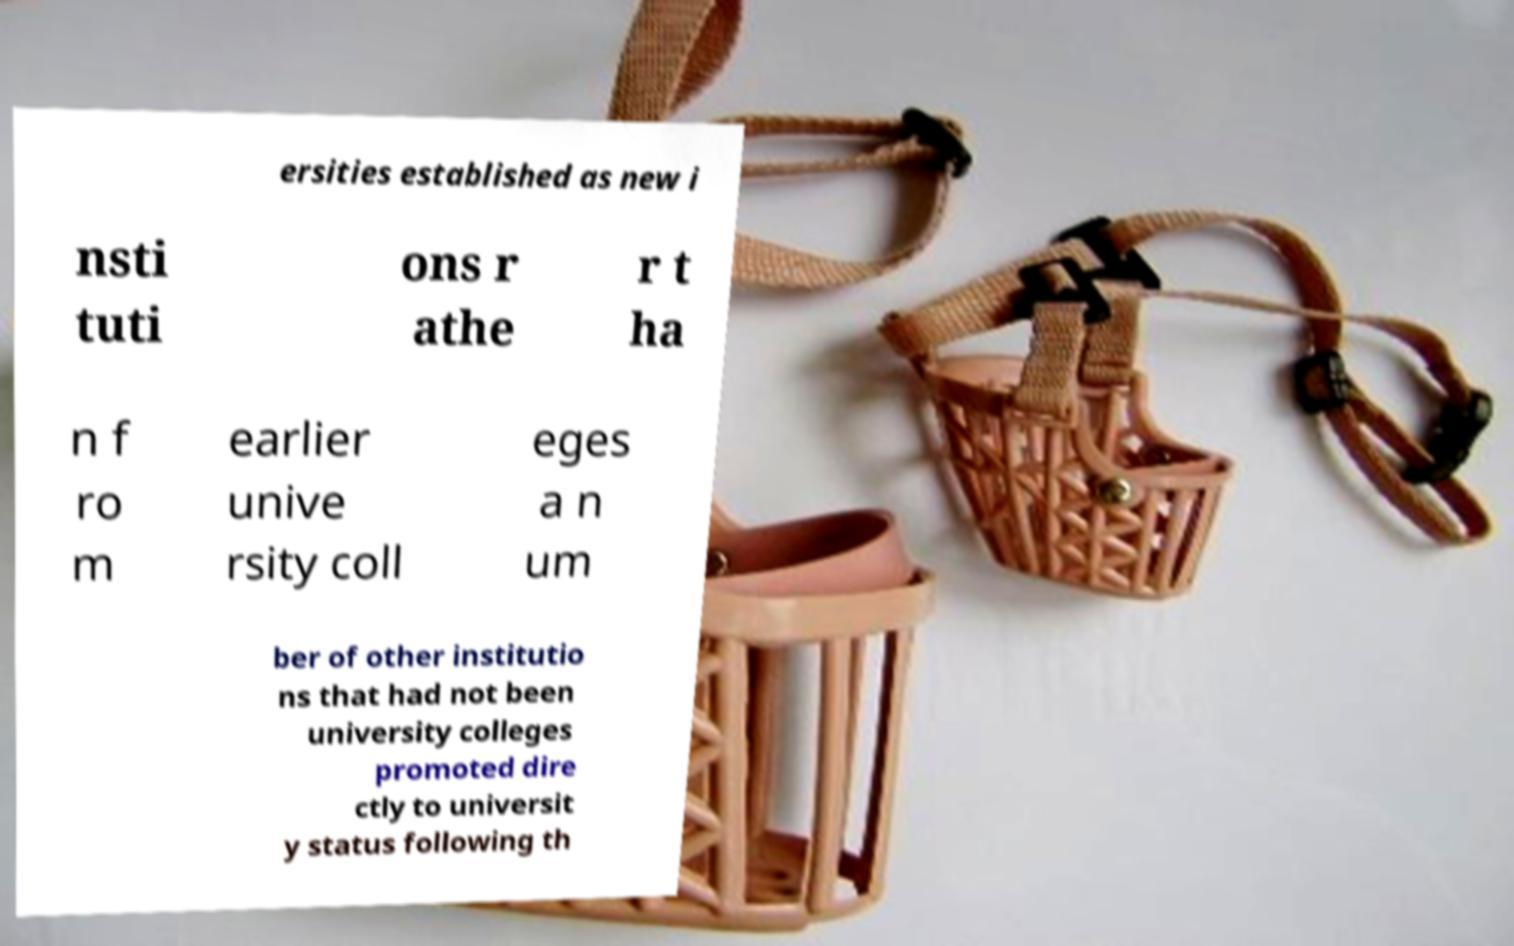Could you extract and type out the text from this image? ersities established as new i nsti tuti ons r athe r t ha n f ro m earlier unive rsity coll eges a n um ber of other institutio ns that had not been university colleges promoted dire ctly to universit y status following th 